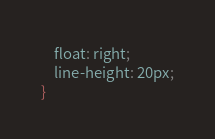<code> <loc_0><loc_0><loc_500><loc_500><_CSS_>    float: right;
    line-height: 20px;
}






</code> 